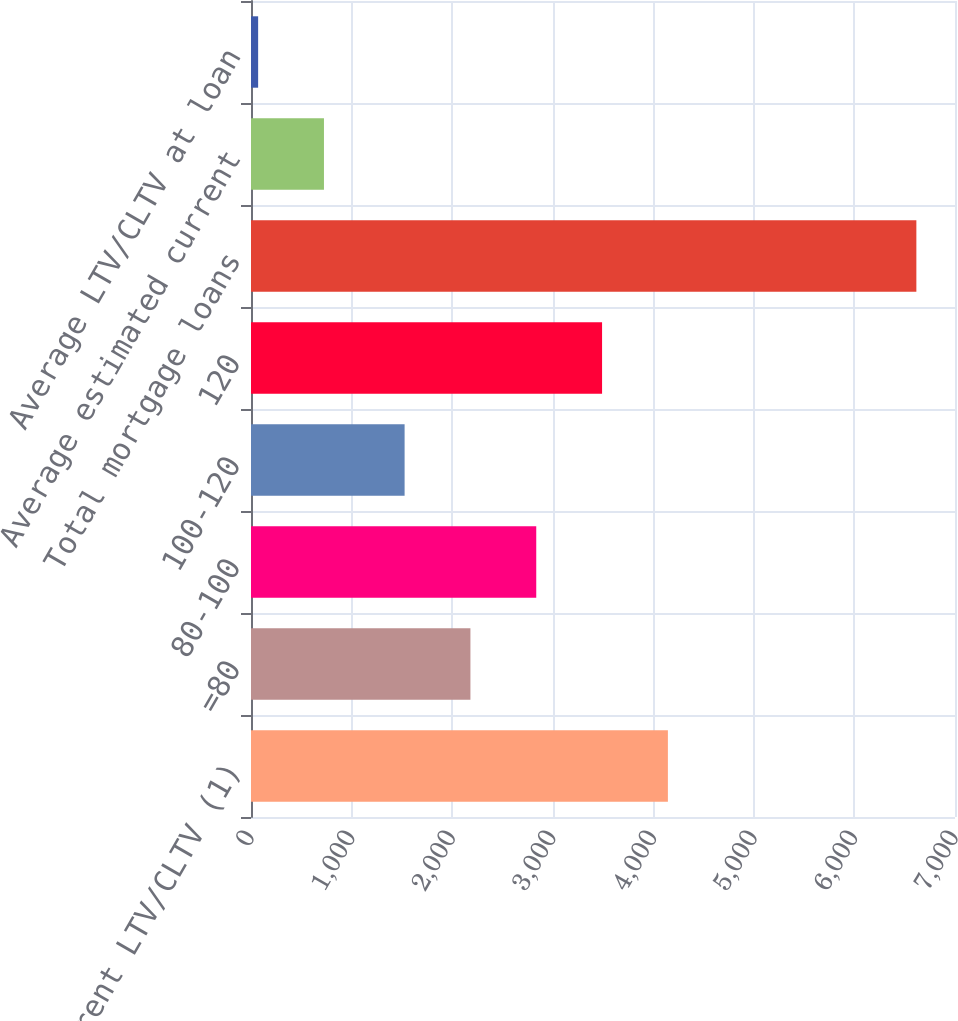Convert chart to OTSL. <chart><loc_0><loc_0><loc_500><loc_500><bar_chart><fcel>Current LTV/CLTV (1)<fcel>=80<fcel>80-100<fcel>100-120<fcel>120<fcel>Total mortgage loans<fcel>Average estimated current<fcel>Average LTV/CLTV at loan<nl><fcel>4145.22<fcel>2181.78<fcel>2836.26<fcel>1527.3<fcel>3490.74<fcel>6615.8<fcel>725.48<fcel>71<nl></chart> 